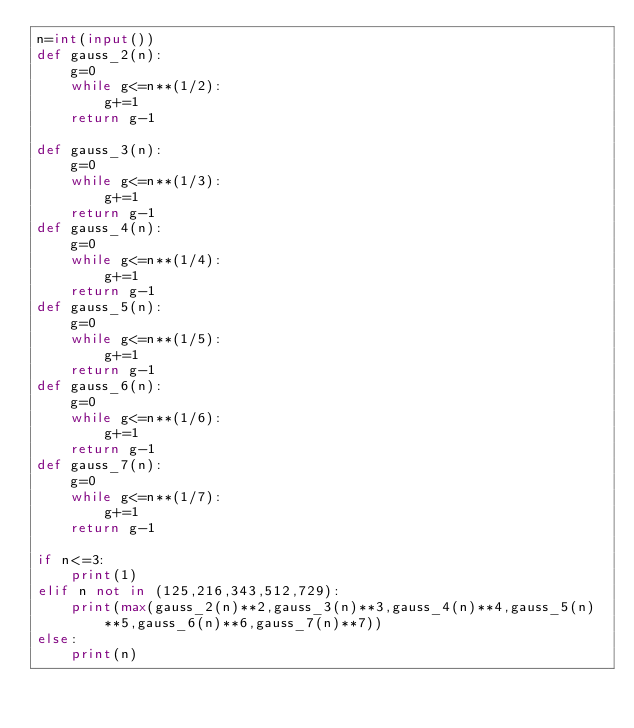<code> <loc_0><loc_0><loc_500><loc_500><_Python_>n=int(input())
def gauss_2(n):
    g=0
    while g<=n**(1/2):
        g+=1
    return g-1

def gauss_3(n):
    g=0
    while g<=n**(1/3):
        g+=1
    return g-1
def gauss_4(n):
    g=0
    while g<=n**(1/4):
        g+=1
    return g-1
def gauss_5(n):
    g=0
    while g<=n**(1/5):
        g+=1
    return g-1
def gauss_6(n):
    g=0
    while g<=n**(1/6):
        g+=1
    return g-1
def gauss_7(n):
    g=0
    while g<=n**(1/7):
        g+=1
    return g-1

if n<=3:
    print(1)
elif n not in (125,216,343,512,729):
    print(max(gauss_2(n)**2,gauss_3(n)**3,gauss_4(n)**4,gauss_5(n)**5,gauss_6(n)**6,gauss_7(n)**7))
else:
    print(n)</code> 